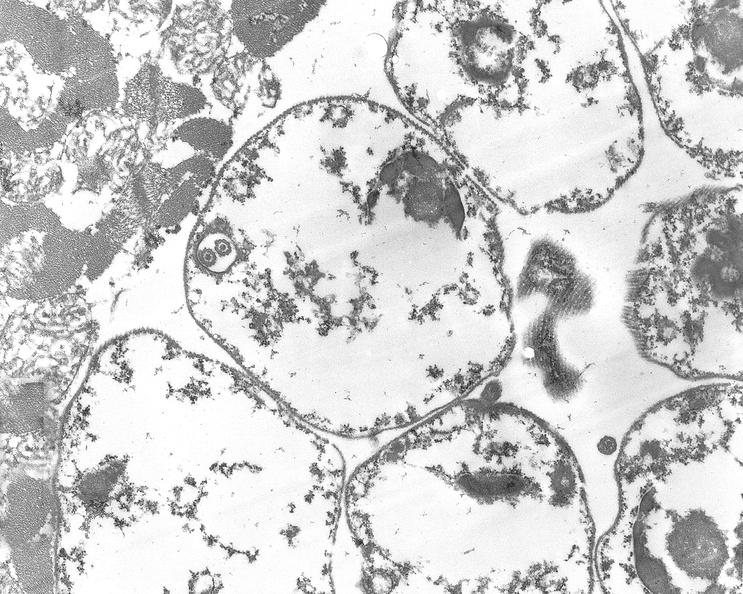s chronic ischemia present?
Answer the question using a single word or phrase. No 